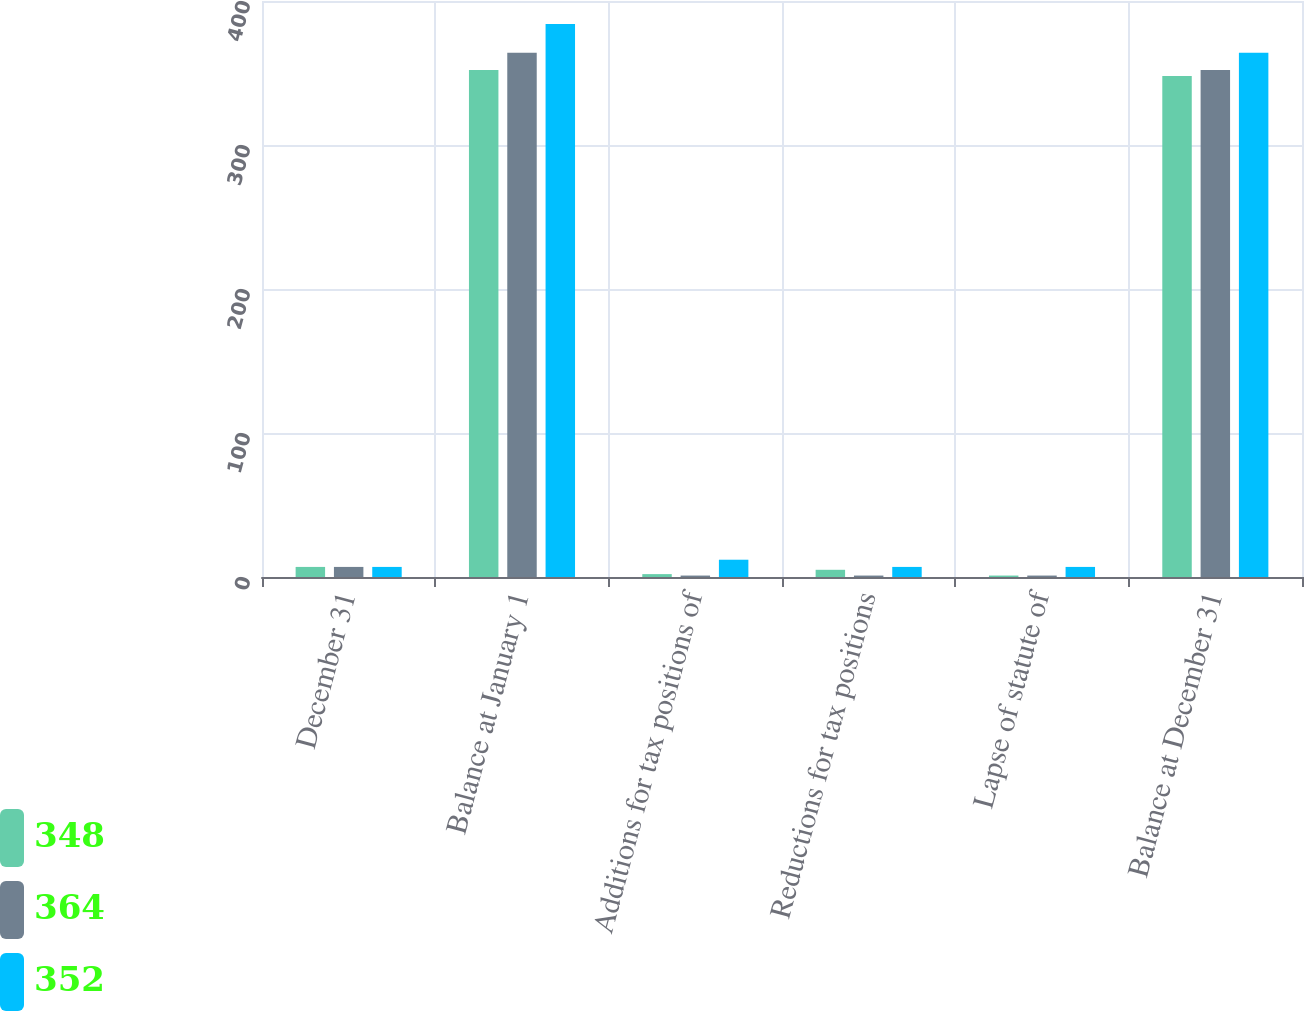Convert chart to OTSL. <chart><loc_0><loc_0><loc_500><loc_500><stacked_bar_chart><ecel><fcel>December 31<fcel>Balance at January 1<fcel>Additions for tax positions of<fcel>Reductions for tax positions<fcel>Lapse of statute of<fcel>Balance at December 31<nl><fcel>348<fcel>7<fcel>352<fcel>2<fcel>5<fcel>1<fcel>348<nl><fcel>364<fcel>7<fcel>364<fcel>1<fcel>1<fcel>1<fcel>352<nl><fcel>352<fcel>7<fcel>384<fcel>12<fcel>7<fcel>7<fcel>364<nl></chart> 